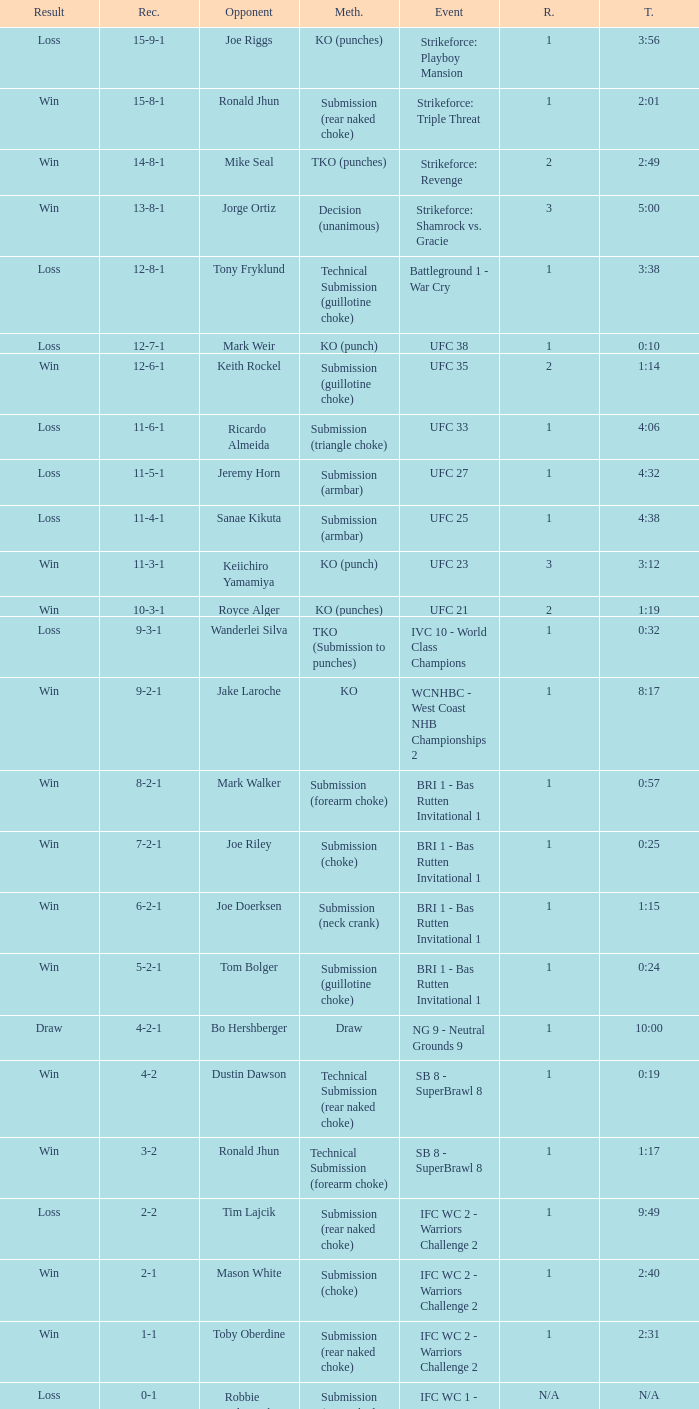What was the resolution for the fight against tom bolger by submission (guillotine choke)? Win. 